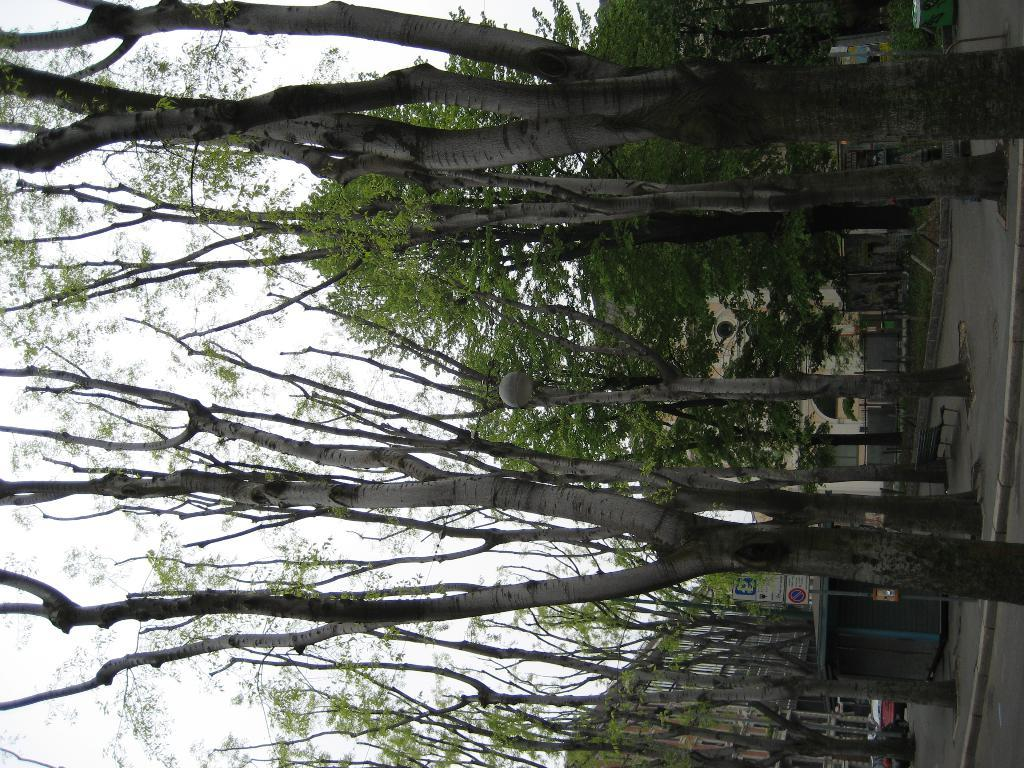What is located in the center of the picture? There are trees in the center of the picture. What can be seen in the center of the background? There are buildings in the center of the background. How many cushions are on the ground near the trees in the image? There is no mention of cushions in the image; it features trees and buildings. Are there any dinosaurs visible in the image? There are no dinosaurs present in the image. 